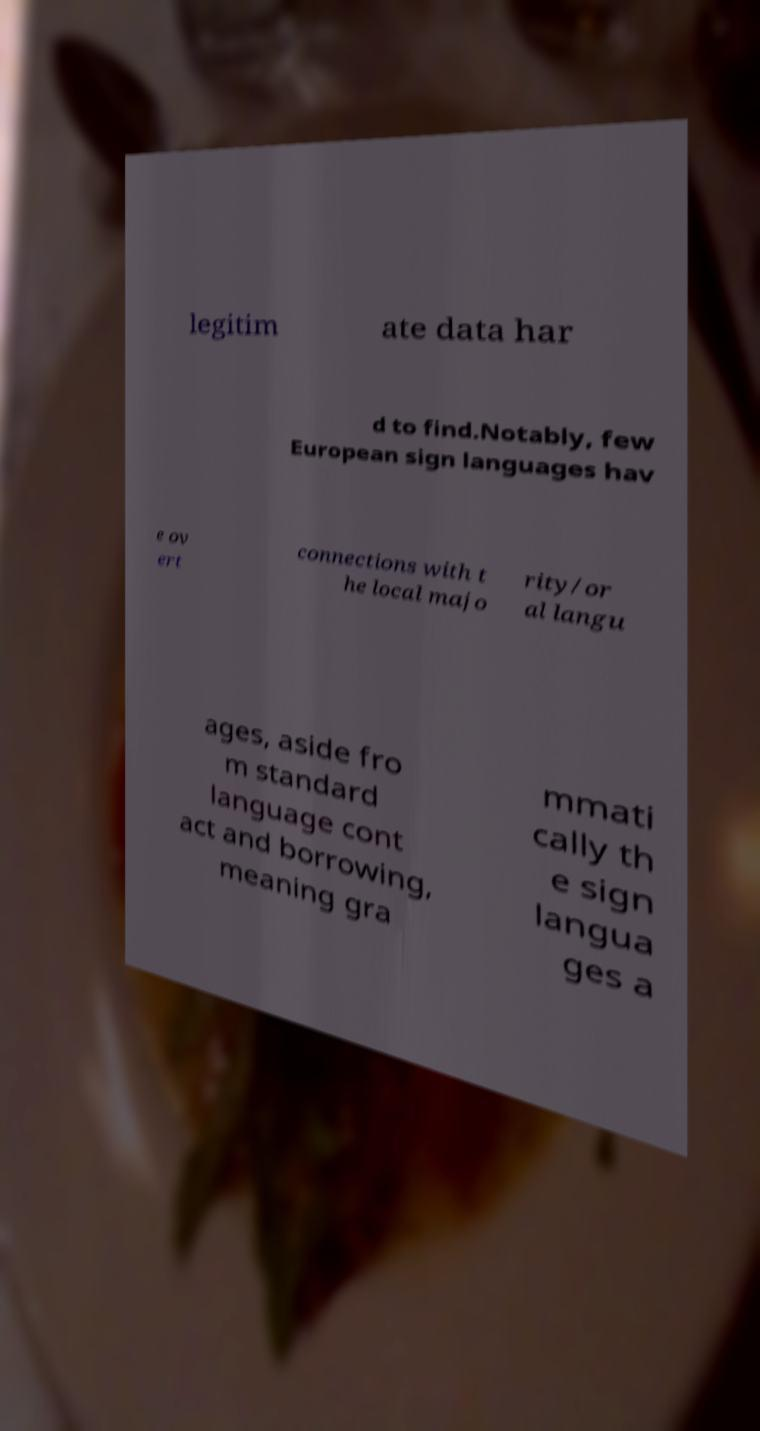Can you read and provide the text displayed in the image?This photo seems to have some interesting text. Can you extract and type it out for me? legitim ate data har d to find.Notably, few European sign languages hav e ov ert connections with t he local majo rity/or al langu ages, aside fro m standard language cont act and borrowing, meaning gra mmati cally th e sign langua ges a 